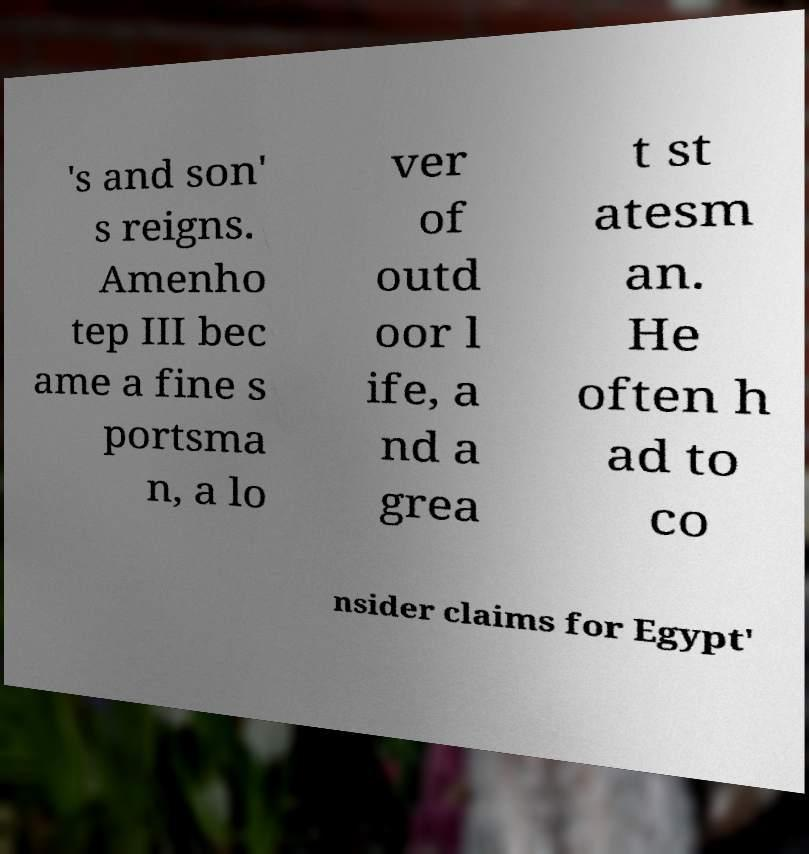I need the written content from this picture converted into text. Can you do that? 's and son' s reigns. Amenho tep III bec ame a fine s portsma n, a lo ver of outd oor l ife, a nd a grea t st atesm an. He often h ad to co nsider claims for Egypt' 